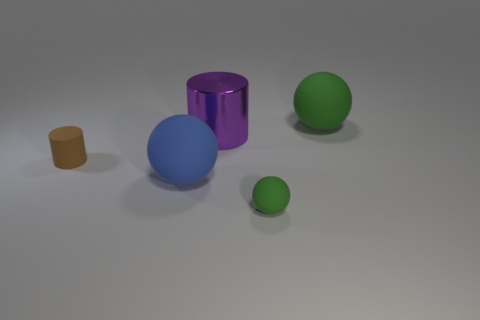Subtract all green matte balls. How many balls are left? 1 Subtract 1 balls. How many balls are left? 2 Add 4 small green things. How many objects exist? 9 Subtract all cylinders. How many objects are left? 3 Subtract 1 purple cylinders. How many objects are left? 4 Subtract all big green spheres. Subtract all matte cylinders. How many objects are left? 3 Add 3 tiny green matte things. How many tiny green matte things are left? 4 Add 1 purple shiny cylinders. How many purple shiny cylinders exist? 2 